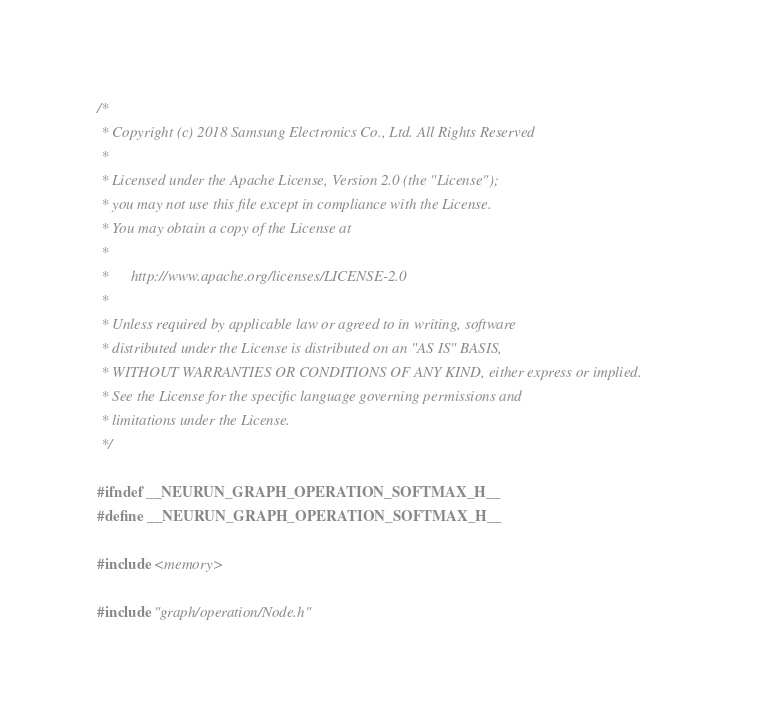<code> <loc_0><loc_0><loc_500><loc_500><_C_>/*
 * Copyright (c) 2018 Samsung Electronics Co., Ltd. All Rights Reserved
 *
 * Licensed under the Apache License, Version 2.0 (the "License");
 * you may not use this file except in compliance with the License.
 * You may obtain a copy of the License at
 *
 *      http://www.apache.org/licenses/LICENSE-2.0
 *
 * Unless required by applicable law or agreed to in writing, software
 * distributed under the License is distributed on an "AS IS" BASIS,
 * WITHOUT WARRANTIES OR CONDITIONS OF ANY KIND, either express or implied.
 * See the License for the specific language governing permissions and
 * limitations under the License.
 */

#ifndef __NEURUN_GRAPH_OPERATION_SOFTMAX_H__
#define __NEURUN_GRAPH_OPERATION_SOFTMAX_H__

#include <memory>

#include "graph/operation/Node.h"
</code> 